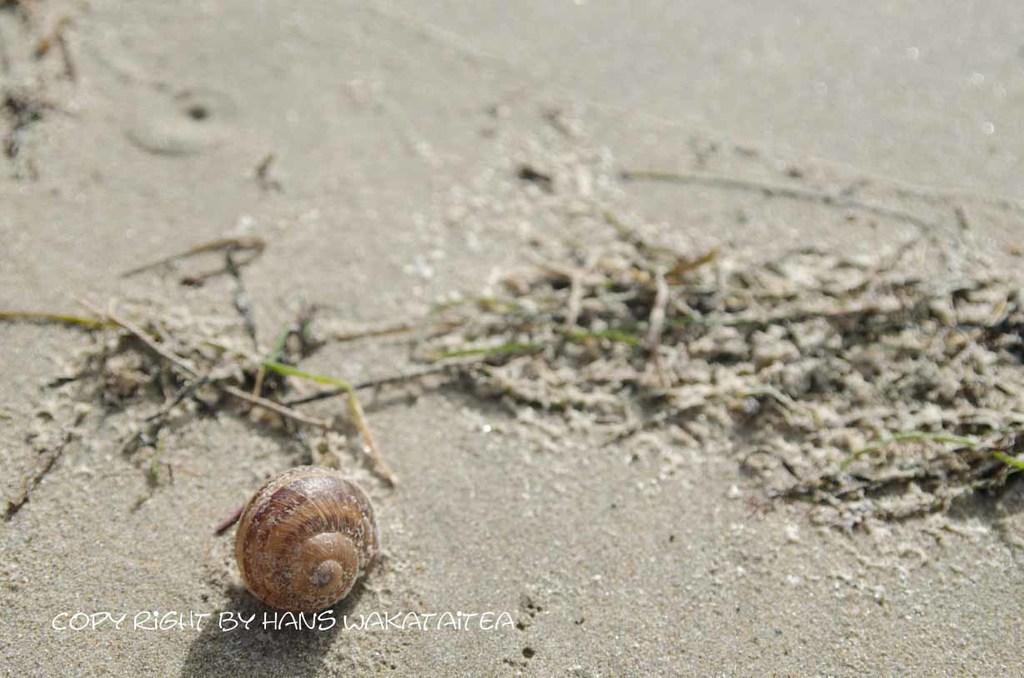In one or two sentences, can you explain what this image depicts? In this image I can see the shell on the grey color mud. The shell is in brown color. To the side I can see the grass. 